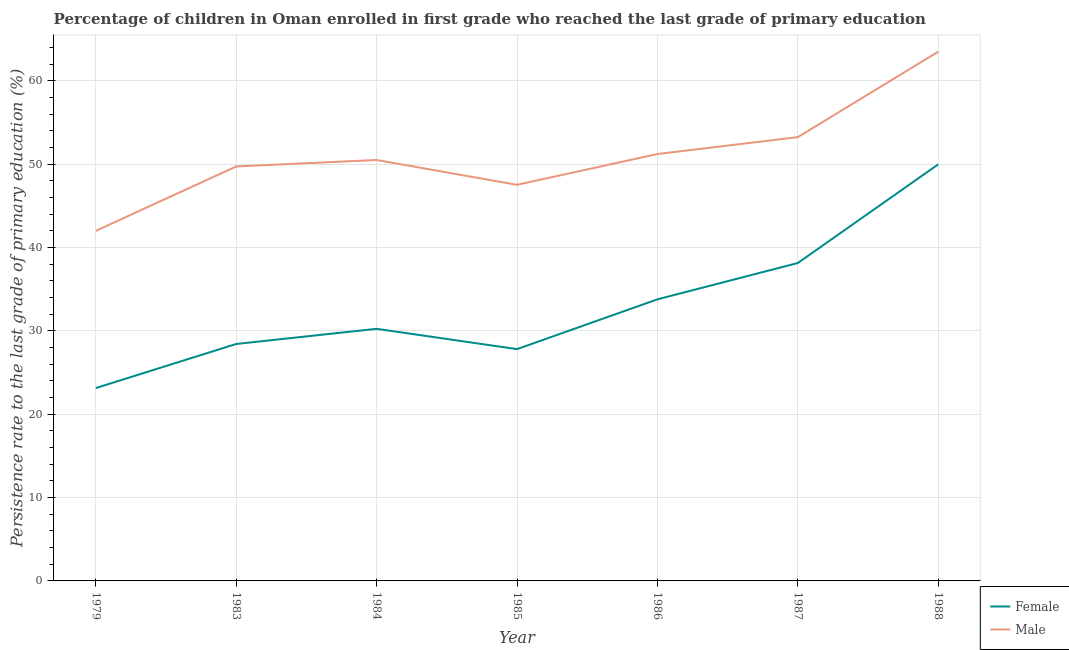Is the number of lines equal to the number of legend labels?
Provide a short and direct response. Yes. What is the persistence rate of female students in 1985?
Ensure brevity in your answer.  27.81. Across all years, what is the maximum persistence rate of female students?
Provide a succinct answer. 49.98. Across all years, what is the minimum persistence rate of male students?
Provide a succinct answer. 42.01. In which year was the persistence rate of female students maximum?
Offer a terse response. 1988. In which year was the persistence rate of female students minimum?
Give a very brief answer. 1979. What is the total persistence rate of male students in the graph?
Offer a very short reply. 357.74. What is the difference between the persistence rate of female students in 1983 and that in 1985?
Ensure brevity in your answer.  0.62. What is the difference between the persistence rate of female students in 1986 and the persistence rate of male students in 1985?
Keep it short and to the point. -13.74. What is the average persistence rate of male students per year?
Offer a terse response. 51.11. In the year 1987, what is the difference between the persistence rate of female students and persistence rate of male students?
Provide a short and direct response. -15.1. What is the ratio of the persistence rate of male students in 1979 to that in 1986?
Offer a terse response. 0.82. Is the persistence rate of male students in 1979 less than that in 1988?
Offer a terse response. Yes. Is the difference between the persistence rate of male students in 1983 and 1986 greater than the difference between the persistence rate of female students in 1983 and 1986?
Make the answer very short. Yes. What is the difference between the highest and the second highest persistence rate of male students?
Keep it short and to the point. 10.25. What is the difference between the highest and the lowest persistence rate of male students?
Your response must be concise. 21.5. In how many years, is the persistence rate of female students greater than the average persistence rate of female students taken over all years?
Give a very brief answer. 3. Is the sum of the persistence rate of female students in 1984 and 1988 greater than the maximum persistence rate of male students across all years?
Your answer should be compact. Yes. Does the persistence rate of female students monotonically increase over the years?
Offer a very short reply. No. Is the persistence rate of male students strictly greater than the persistence rate of female students over the years?
Keep it short and to the point. Yes. Is the persistence rate of female students strictly less than the persistence rate of male students over the years?
Keep it short and to the point. Yes. How many years are there in the graph?
Offer a very short reply. 7. Are the values on the major ticks of Y-axis written in scientific E-notation?
Keep it short and to the point. No. Does the graph contain any zero values?
Your answer should be very brief. No. Where does the legend appear in the graph?
Your response must be concise. Bottom right. What is the title of the graph?
Provide a succinct answer. Percentage of children in Oman enrolled in first grade who reached the last grade of primary education. Does "Mobile cellular" appear as one of the legend labels in the graph?
Make the answer very short. No. What is the label or title of the Y-axis?
Offer a very short reply. Persistence rate to the last grade of primary education (%). What is the Persistence rate to the last grade of primary education (%) in Female in 1979?
Give a very brief answer. 23.14. What is the Persistence rate to the last grade of primary education (%) of Male in 1979?
Make the answer very short. 42.01. What is the Persistence rate to the last grade of primary education (%) in Female in 1983?
Give a very brief answer. 28.43. What is the Persistence rate to the last grade of primary education (%) of Male in 1983?
Make the answer very short. 49.73. What is the Persistence rate to the last grade of primary education (%) in Female in 1984?
Your answer should be very brief. 30.25. What is the Persistence rate to the last grade of primary education (%) in Male in 1984?
Give a very brief answer. 50.51. What is the Persistence rate to the last grade of primary education (%) in Female in 1985?
Offer a very short reply. 27.81. What is the Persistence rate to the last grade of primary education (%) of Male in 1985?
Give a very brief answer. 47.53. What is the Persistence rate to the last grade of primary education (%) in Female in 1986?
Ensure brevity in your answer.  33.79. What is the Persistence rate to the last grade of primary education (%) of Male in 1986?
Make the answer very short. 51.22. What is the Persistence rate to the last grade of primary education (%) of Female in 1987?
Ensure brevity in your answer.  38.14. What is the Persistence rate to the last grade of primary education (%) in Male in 1987?
Your response must be concise. 53.25. What is the Persistence rate to the last grade of primary education (%) of Female in 1988?
Ensure brevity in your answer.  49.98. What is the Persistence rate to the last grade of primary education (%) of Male in 1988?
Ensure brevity in your answer.  63.5. Across all years, what is the maximum Persistence rate to the last grade of primary education (%) of Female?
Provide a short and direct response. 49.98. Across all years, what is the maximum Persistence rate to the last grade of primary education (%) of Male?
Make the answer very short. 63.5. Across all years, what is the minimum Persistence rate to the last grade of primary education (%) of Female?
Make the answer very short. 23.14. Across all years, what is the minimum Persistence rate to the last grade of primary education (%) of Male?
Provide a short and direct response. 42.01. What is the total Persistence rate to the last grade of primary education (%) in Female in the graph?
Provide a succinct answer. 231.55. What is the total Persistence rate to the last grade of primary education (%) in Male in the graph?
Your answer should be very brief. 357.74. What is the difference between the Persistence rate to the last grade of primary education (%) of Female in 1979 and that in 1983?
Ensure brevity in your answer.  -5.29. What is the difference between the Persistence rate to the last grade of primary education (%) of Male in 1979 and that in 1983?
Keep it short and to the point. -7.73. What is the difference between the Persistence rate to the last grade of primary education (%) in Female in 1979 and that in 1984?
Your answer should be very brief. -7.11. What is the difference between the Persistence rate to the last grade of primary education (%) of Female in 1979 and that in 1985?
Keep it short and to the point. -4.67. What is the difference between the Persistence rate to the last grade of primary education (%) in Male in 1979 and that in 1985?
Provide a succinct answer. -5.52. What is the difference between the Persistence rate to the last grade of primary education (%) in Female in 1979 and that in 1986?
Your response must be concise. -10.64. What is the difference between the Persistence rate to the last grade of primary education (%) of Male in 1979 and that in 1986?
Keep it short and to the point. -9.21. What is the difference between the Persistence rate to the last grade of primary education (%) of Female in 1979 and that in 1987?
Your answer should be very brief. -15. What is the difference between the Persistence rate to the last grade of primary education (%) in Male in 1979 and that in 1987?
Ensure brevity in your answer.  -11.24. What is the difference between the Persistence rate to the last grade of primary education (%) of Female in 1979 and that in 1988?
Keep it short and to the point. -26.84. What is the difference between the Persistence rate to the last grade of primary education (%) in Male in 1979 and that in 1988?
Make the answer very short. -21.5. What is the difference between the Persistence rate to the last grade of primary education (%) of Female in 1983 and that in 1984?
Your response must be concise. -1.82. What is the difference between the Persistence rate to the last grade of primary education (%) of Male in 1983 and that in 1984?
Offer a terse response. -0.77. What is the difference between the Persistence rate to the last grade of primary education (%) in Female in 1983 and that in 1985?
Offer a terse response. 0.62. What is the difference between the Persistence rate to the last grade of primary education (%) in Male in 1983 and that in 1985?
Keep it short and to the point. 2.2. What is the difference between the Persistence rate to the last grade of primary education (%) in Female in 1983 and that in 1986?
Your answer should be very brief. -5.35. What is the difference between the Persistence rate to the last grade of primary education (%) in Male in 1983 and that in 1986?
Your answer should be compact. -1.49. What is the difference between the Persistence rate to the last grade of primary education (%) in Female in 1983 and that in 1987?
Your answer should be very brief. -9.71. What is the difference between the Persistence rate to the last grade of primary education (%) in Male in 1983 and that in 1987?
Provide a short and direct response. -3.52. What is the difference between the Persistence rate to the last grade of primary education (%) of Female in 1983 and that in 1988?
Give a very brief answer. -21.55. What is the difference between the Persistence rate to the last grade of primary education (%) in Male in 1983 and that in 1988?
Ensure brevity in your answer.  -13.77. What is the difference between the Persistence rate to the last grade of primary education (%) in Female in 1984 and that in 1985?
Offer a very short reply. 2.44. What is the difference between the Persistence rate to the last grade of primary education (%) of Male in 1984 and that in 1985?
Ensure brevity in your answer.  2.98. What is the difference between the Persistence rate to the last grade of primary education (%) in Female in 1984 and that in 1986?
Make the answer very short. -3.54. What is the difference between the Persistence rate to the last grade of primary education (%) in Male in 1984 and that in 1986?
Ensure brevity in your answer.  -0.71. What is the difference between the Persistence rate to the last grade of primary education (%) of Female in 1984 and that in 1987?
Provide a short and direct response. -7.89. What is the difference between the Persistence rate to the last grade of primary education (%) of Male in 1984 and that in 1987?
Give a very brief answer. -2.74. What is the difference between the Persistence rate to the last grade of primary education (%) of Female in 1984 and that in 1988?
Provide a short and direct response. -19.73. What is the difference between the Persistence rate to the last grade of primary education (%) in Male in 1984 and that in 1988?
Your answer should be compact. -13. What is the difference between the Persistence rate to the last grade of primary education (%) of Female in 1985 and that in 1986?
Keep it short and to the point. -5.97. What is the difference between the Persistence rate to the last grade of primary education (%) in Male in 1985 and that in 1986?
Offer a very short reply. -3.69. What is the difference between the Persistence rate to the last grade of primary education (%) in Female in 1985 and that in 1987?
Your answer should be compact. -10.33. What is the difference between the Persistence rate to the last grade of primary education (%) of Male in 1985 and that in 1987?
Provide a short and direct response. -5.72. What is the difference between the Persistence rate to the last grade of primary education (%) of Female in 1985 and that in 1988?
Keep it short and to the point. -22.17. What is the difference between the Persistence rate to the last grade of primary education (%) of Male in 1985 and that in 1988?
Your response must be concise. -15.97. What is the difference between the Persistence rate to the last grade of primary education (%) of Female in 1986 and that in 1987?
Offer a very short reply. -4.36. What is the difference between the Persistence rate to the last grade of primary education (%) in Male in 1986 and that in 1987?
Keep it short and to the point. -2.03. What is the difference between the Persistence rate to the last grade of primary education (%) of Female in 1986 and that in 1988?
Offer a very short reply. -16.2. What is the difference between the Persistence rate to the last grade of primary education (%) of Male in 1986 and that in 1988?
Offer a very short reply. -12.28. What is the difference between the Persistence rate to the last grade of primary education (%) of Female in 1987 and that in 1988?
Give a very brief answer. -11.84. What is the difference between the Persistence rate to the last grade of primary education (%) of Male in 1987 and that in 1988?
Your answer should be very brief. -10.25. What is the difference between the Persistence rate to the last grade of primary education (%) of Female in 1979 and the Persistence rate to the last grade of primary education (%) of Male in 1983?
Give a very brief answer. -26.59. What is the difference between the Persistence rate to the last grade of primary education (%) in Female in 1979 and the Persistence rate to the last grade of primary education (%) in Male in 1984?
Make the answer very short. -27.36. What is the difference between the Persistence rate to the last grade of primary education (%) in Female in 1979 and the Persistence rate to the last grade of primary education (%) in Male in 1985?
Ensure brevity in your answer.  -24.39. What is the difference between the Persistence rate to the last grade of primary education (%) of Female in 1979 and the Persistence rate to the last grade of primary education (%) of Male in 1986?
Provide a succinct answer. -28.08. What is the difference between the Persistence rate to the last grade of primary education (%) of Female in 1979 and the Persistence rate to the last grade of primary education (%) of Male in 1987?
Offer a terse response. -30.1. What is the difference between the Persistence rate to the last grade of primary education (%) in Female in 1979 and the Persistence rate to the last grade of primary education (%) in Male in 1988?
Offer a terse response. -40.36. What is the difference between the Persistence rate to the last grade of primary education (%) in Female in 1983 and the Persistence rate to the last grade of primary education (%) in Male in 1984?
Ensure brevity in your answer.  -22.07. What is the difference between the Persistence rate to the last grade of primary education (%) in Female in 1983 and the Persistence rate to the last grade of primary education (%) in Male in 1985?
Your answer should be very brief. -19.1. What is the difference between the Persistence rate to the last grade of primary education (%) of Female in 1983 and the Persistence rate to the last grade of primary education (%) of Male in 1986?
Your answer should be very brief. -22.79. What is the difference between the Persistence rate to the last grade of primary education (%) of Female in 1983 and the Persistence rate to the last grade of primary education (%) of Male in 1987?
Make the answer very short. -24.82. What is the difference between the Persistence rate to the last grade of primary education (%) in Female in 1983 and the Persistence rate to the last grade of primary education (%) in Male in 1988?
Offer a terse response. -35.07. What is the difference between the Persistence rate to the last grade of primary education (%) of Female in 1984 and the Persistence rate to the last grade of primary education (%) of Male in 1985?
Offer a terse response. -17.28. What is the difference between the Persistence rate to the last grade of primary education (%) of Female in 1984 and the Persistence rate to the last grade of primary education (%) of Male in 1986?
Offer a very short reply. -20.97. What is the difference between the Persistence rate to the last grade of primary education (%) in Female in 1984 and the Persistence rate to the last grade of primary education (%) in Male in 1987?
Keep it short and to the point. -23. What is the difference between the Persistence rate to the last grade of primary education (%) in Female in 1984 and the Persistence rate to the last grade of primary education (%) in Male in 1988?
Keep it short and to the point. -33.25. What is the difference between the Persistence rate to the last grade of primary education (%) of Female in 1985 and the Persistence rate to the last grade of primary education (%) of Male in 1986?
Provide a short and direct response. -23.41. What is the difference between the Persistence rate to the last grade of primary education (%) of Female in 1985 and the Persistence rate to the last grade of primary education (%) of Male in 1987?
Ensure brevity in your answer.  -25.43. What is the difference between the Persistence rate to the last grade of primary education (%) of Female in 1985 and the Persistence rate to the last grade of primary education (%) of Male in 1988?
Keep it short and to the point. -35.69. What is the difference between the Persistence rate to the last grade of primary education (%) in Female in 1986 and the Persistence rate to the last grade of primary education (%) in Male in 1987?
Provide a short and direct response. -19.46. What is the difference between the Persistence rate to the last grade of primary education (%) in Female in 1986 and the Persistence rate to the last grade of primary education (%) in Male in 1988?
Your answer should be compact. -29.72. What is the difference between the Persistence rate to the last grade of primary education (%) of Female in 1987 and the Persistence rate to the last grade of primary education (%) of Male in 1988?
Provide a succinct answer. -25.36. What is the average Persistence rate to the last grade of primary education (%) of Female per year?
Keep it short and to the point. 33.08. What is the average Persistence rate to the last grade of primary education (%) in Male per year?
Provide a succinct answer. 51.11. In the year 1979, what is the difference between the Persistence rate to the last grade of primary education (%) in Female and Persistence rate to the last grade of primary education (%) in Male?
Your answer should be compact. -18.86. In the year 1983, what is the difference between the Persistence rate to the last grade of primary education (%) in Female and Persistence rate to the last grade of primary education (%) in Male?
Your response must be concise. -21.3. In the year 1984, what is the difference between the Persistence rate to the last grade of primary education (%) of Female and Persistence rate to the last grade of primary education (%) of Male?
Give a very brief answer. -20.26. In the year 1985, what is the difference between the Persistence rate to the last grade of primary education (%) of Female and Persistence rate to the last grade of primary education (%) of Male?
Provide a succinct answer. -19.72. In the year 1986, what is the difference between the Persistence rate to the last grade of primary education (%) of Female and Persistence rate to the last grade of primary education (%) of Male?
Ensure brevity in your answer.  -17.43. In the year 1987, what is the difference between the Persistence rate to the last grade of primary education (%) in Female and Persistence rate to the last grade of primary education (%) in Male?
Your response must be concise. -15.1. In the year 1988, what is the difference between the Persistence rate to the last grade of primary education (%) in Female and Persistence rate to the last grade of primary education (%) in Male?
Your answer should be very brief. -13.52. What is the ratio of the Persistence rate to the last grade of primary education (%) in Female in 1979 to that in 1983?
Your response must be concise. 0.81. What is the ratio of the Persistence rate to the last grade of primary education (%) of Male in 1979 to that in 1983?
Your answer should be very brief. 0.84. What is the ratio of the Persistence rate to the last grade of primary education (%) of Female in 1979 to that in 1984?
Ensure brevity in your answer.  0.77. What is the ratio of the Persistence rate to the last grade of primary education (%) in Male in 1979 to that in 1984?
Offer a very short reply. 0.83. What is the ratio of the Persistence rate to the last grade of primary education (%) in Female in 1979 to that in 1985?
Your response must be concise. 0.83. What is the ratio of the Persistence rate to the last grade of primary education (%) of Male in 1979 to that in 1985?
Offer a very short reply. 0.88. What is the ratio of the Persistence rate to the last grade of primary education (%) of Female in 1979 to that in 1986?
Give a very brief answer. 0.69. What is the ratio of the Persistence rate to the last grade of primary education (%) in Male in 1979 to that in 1986?
Offer a terse response. 0.82. What is the ratio of the Persistence rate to the last grade of primary education (%) in Female in 1979 to that in 1987?
Offer a terse response. 0.61. What is the ratio of the Persistence rate to the last grade of primary education (%) of Male in 1979 to that in 1987?
Ensure brevity in your answer.  0.79. What is the ratio of the Persistence rate to the last grade of primary education (%) of Female in 1979 to that in 1988?
Provide a short and direct response. 0.46. What is the ratio of the Persistence rate to the last grade of primary education (%) of Male in 1979 to that in 1988?
Your answer should be very brief. 0.66. What is the ratio of the Persistence rate to the last grade of primary education (%) of Female in 1983 to that in 1984?
Give a very brief answer. 0.94. What is the ratio of the Persistence rate to the last grade of primary education (%) in Male in 1983 to that in 1984?
Provide a succinct answer. 0.98. What is the ratio of the Persistence rate to the last grade of primary education (%) of Female in 1983 to that in 1985?
Make the answer very short. 1.02. What is the ratio of the Persistence rate to the last grade of primary education (%) of Male in 1983 to that in 1985?
Ensure brevity in your answer.  1.05. What is the ratio of the Persistence rate to the last grade of primary education (%) in Female in 1983 to that in 1986?
Your response must be concise. 0.84. What is the ratio of the Persistence rate to the last grade of primary education (%) of Male in 1983 to that in 1986?
Offer a terse response. 0.97. What is the ratio of the Persistence rate to the last grade of primary education (%) in Female in 1983 to that in 1987?
Keep it short and to the point. 0.75. What is the ratio of the Persistence rate to the last grade of primary education (%) in Male in 1983 to that in 1987?
Offer a very short reply. 0.93. What is the ratio of the Persistence rate to the last grade of primary education (%) of Female in 1983 to that in 1988?
Give a very brief answer. 0.57. What is the ratio of the Persistence rate to the last grade of primary education (%) in Male in 1983 to that in 1988?
Give a very brief answer. 0.78. What is the ratio of the Persistence rate to the last grade of primary education (%) of Female in 1984 to that in 1985?
Keep it short and to the point. 1.09. What is the ratio of the Persistence rate to the last grade of primary education (%) of Male in 1984 to that in 1985?
Offer a terse response. 1.06. What is the ratio of the Persistence rate to the last grade of primary education (%) of Female in 1984 to that in 1986?
Give a very brief answer. 0.9. What is the ratio of the Persistence rate to the last grade of primary education (%) of Male in 1984 to that in 1986?
Your answer should be very brief. 0.99. What is the ratio of the Persistence rate to the last grade of primary education (%) in Female in 1984 to that in 1987?
Your answer should be very brief. 0.79. What is the ratio of the Persistence rate to the last grade of primary education (%) of Male in 1984 to that in 1987?
Make the answer very short. 0.95. What is the ratio of the Persistence rate to the last grade of primary education (%) in Female in 1984 to that in 1988?
Ensure brevity in your answer.  0.61. What is the ratio of the Persistence rate to the last grade of primary education (%) in Male in 1984 to that in 1988?
Make the answer very short. 0.8. What is the ratio of the Persistence rate to the last grade of primary education (%) of Female in 1985 to that in 1986?
Keep it short and to the point. 0.82. What is the ratio of the Persistence rate to the last grade of primary education (%) of Male in 1985 to that in 1986?
Offer a very short reply. 0.93. What is the ratio of the Persistence rate to the last grade of primary education (%) in Female in 1985 to that in 1987?
Ensure brevity in your answer.  0.73. What is the ratio of the Persistence rate to the last grade of primary education (%) of Male in 1985 to that in 1987?
Your answer should be very brief. 0.89. What is the ratio of the Persistence rate to the last grade of primary education (%) of Female in 1985 to that in 1988?
Offer a very short reply. 0.56. What is the ratio of the Persistence rate to the last grade of primary education (%) in Male in 1985 to that in 1988?
Offer a terse response. 0.75. What is the ratio of the Persistence rate to the last grade of primary education (%) in Female in 1986 to that in 1987?
Provide a succinct answer. 0.89. What is the ratio of the Persistence rate to the last grade of primary education (%) of Male in 1986 to that in 1987?
Keep it short and to the point. 0.96. What is the ratio of the Persistence rate to the last grade of primary education (%) in Female in 1986 to that in 1988?
Your answer should be very brief. 0.68. What is the ratio of the Persistence rate to the last grade of primary education (%) in Male in 1986 to that in 1988?
Offer a very short reply. 0.81. What is the ratio of the Persistence rate to the last grade of primary education (%) of Female in 1987 to that in 1988?
Keep it short and to the point. 0.76. What is the ratio of the Persistence rate to the last grade of primary education (%) of Male in 1987 to that in 1988?
Your response must be concise. 0.84. What is the difference between the highest and the second highest Persistence rate to the last grade of primary education (%) of Female?
Give a very brief answer. 11.84. What is the difference between the highest and the second highest Persistence rate to the last grade of primary education (%) in Male?
Offer a very short reply. 10.25. What is the difference between the highest and the lowest Persistence rate to the last grade of primary education (%) in Female?
Keep it short and to the point. 26.84. What is the difference between the highest and the lowest Persistence rate to the last grade of primary education (%) of Male?
Keep it short and to the point. 21.5. 